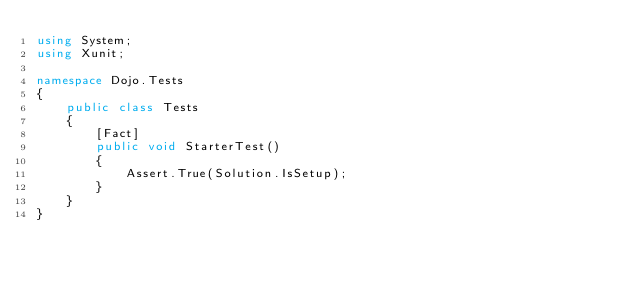<code> <loc_0><loc_0><loc_500><loc_500><_C#_>using System;
using Xunit;

namespace Dojo.Tests
{
    public class Tests
    {
        [Fact]
        public void StarterTest()
        {
            Assert.True(Solution.IsSetup);
        }
    }
}
</code> 